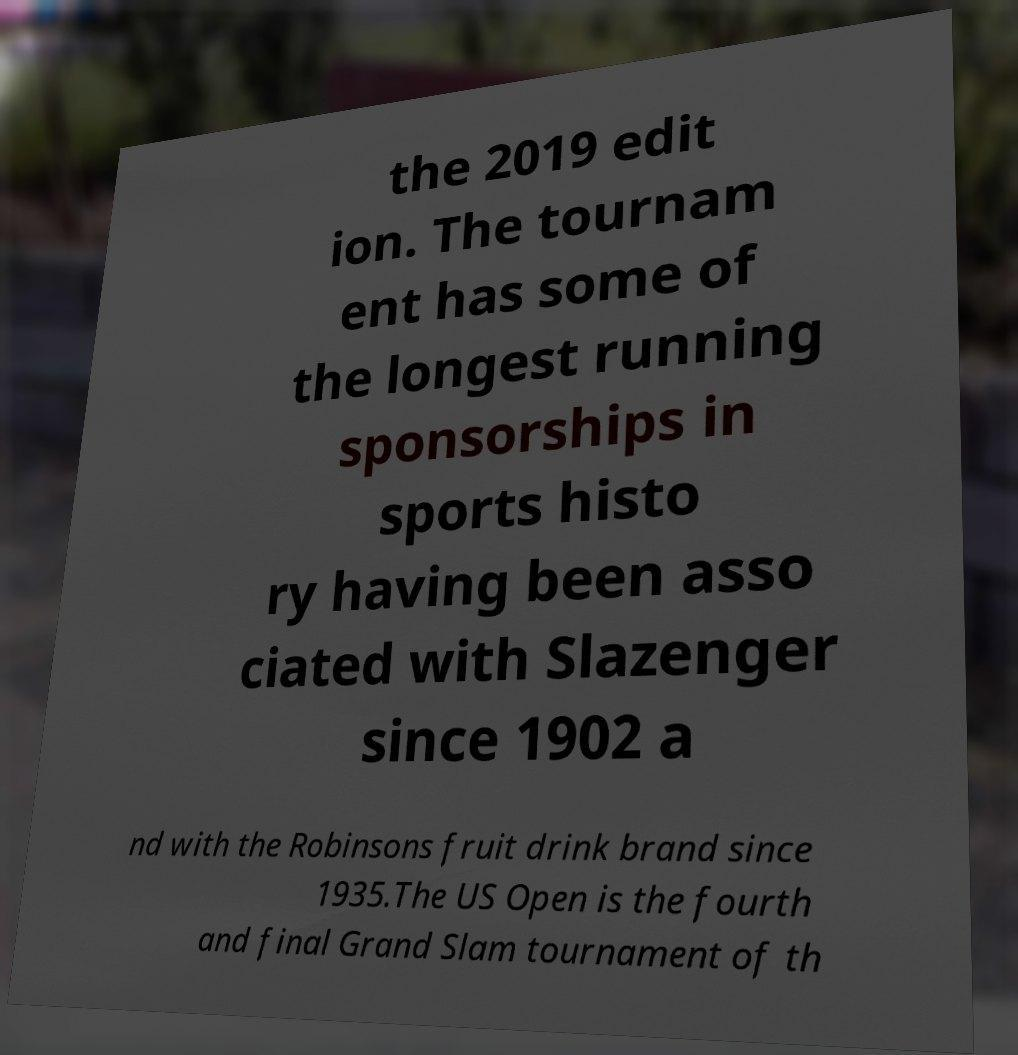What messages or text are displayed in this image? I need them in a readable, typed format. the 2019 edit ion. The tournam ent has some of the longest running sponsorships in sports histo ry having been asso ciated with Slazenger since 1902 a nd with the Robinsons fruit drink brand since 1935.The US Open is the fourth and final Grand Slam tournament of th 